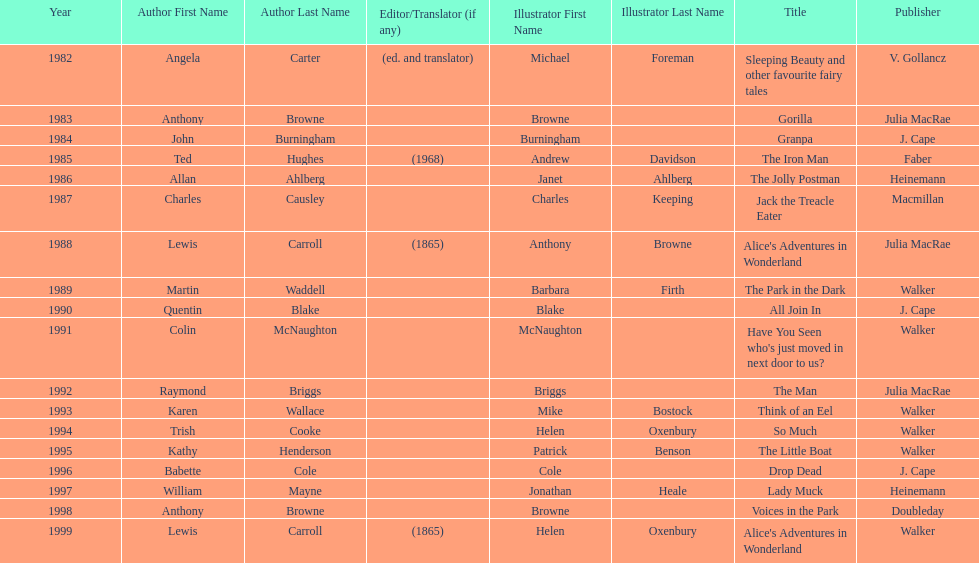Which book won the award a total of 2 times? Alice's Adventures in Wonderland. 